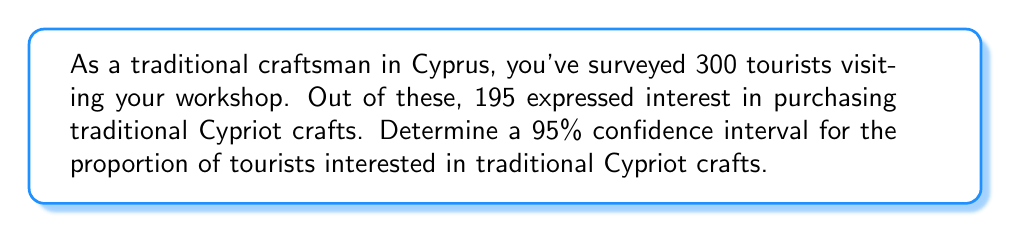Can you solve this math problem? Let's approach this step-by-step:

1) First, we need to calculate the sample proportion $\hat{p}$:
   $\hat{p} = \frac{\text{number of successes}}{\text{sample size}} = \frac{195}{300} = 0.65$

2) For a 95% confidence interval, we use a z-score of 1.96.

3) The formula for the confidence interval is:

   $$\hat{p} \pm z \sqrt{\frac{\hat{p}(1-\hat{p})}{n}}$$

   where $n$ is the sample size.

4) Let's calculate the margin of error:

   $$\text{Margin of Error} = 1.96 \sqrt{\frac{0.65(1-0.65)}{300}}$$
   $$= 1.96 \sqrt{\frac{0.65(0.35)}{300}}$$
   $$= 1.96 \sqrt{0.000758333}$$
   $$= 1.96 (0.0275)$$
   $$= 0.0539$$

5) Now, we can calculate the confidence interval:

   Lower bound: $0.65 - 0.0539 = 0.5961$
   Upper bound: $0.65 + 0.0539 = 0.7039$

6) Therefore, we are 95% confident that the true proportion of tourists interested in traditional Cypriot crafts is between 0.5961 and 0.7039, or between 59.61% and 70.39%.
Answer: (0.5961, 0.7039) 